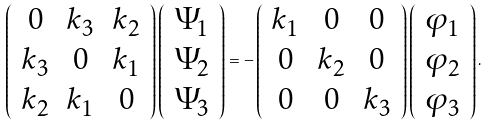Convert formula to latex. <formula><loc_0><loc_0><loc_500><loc_500>\left ( \begin{array} { c c c } 0 & k _ { 3 } & k _ { 2 } \\ k _ { 3 } & 0 & k _ { 1 } \\ k _ { 2 } & k _ { 1 } & 0 \\ \end{array} \right ) \left ( \begin{array} { c } \Psi _ { 1 } \\ \Psi _ { 2 } \\ \Psi _ { 3 } \\ \end{array} \right ) = - \left ( \begin{array} { c c c } k _ { 1 } & 0 & 0 \\ 0 & k _ { 2 } & 0 \\ 0 & 0 & k _ { 3 } \\ \end{array} \right ) \left ( \begin{array} { c } \varphi _ { 1 } \\ \varphi _ { 2 } \\ \varphi _ { 3 } \\ \end{array} \right ) .</formula> 